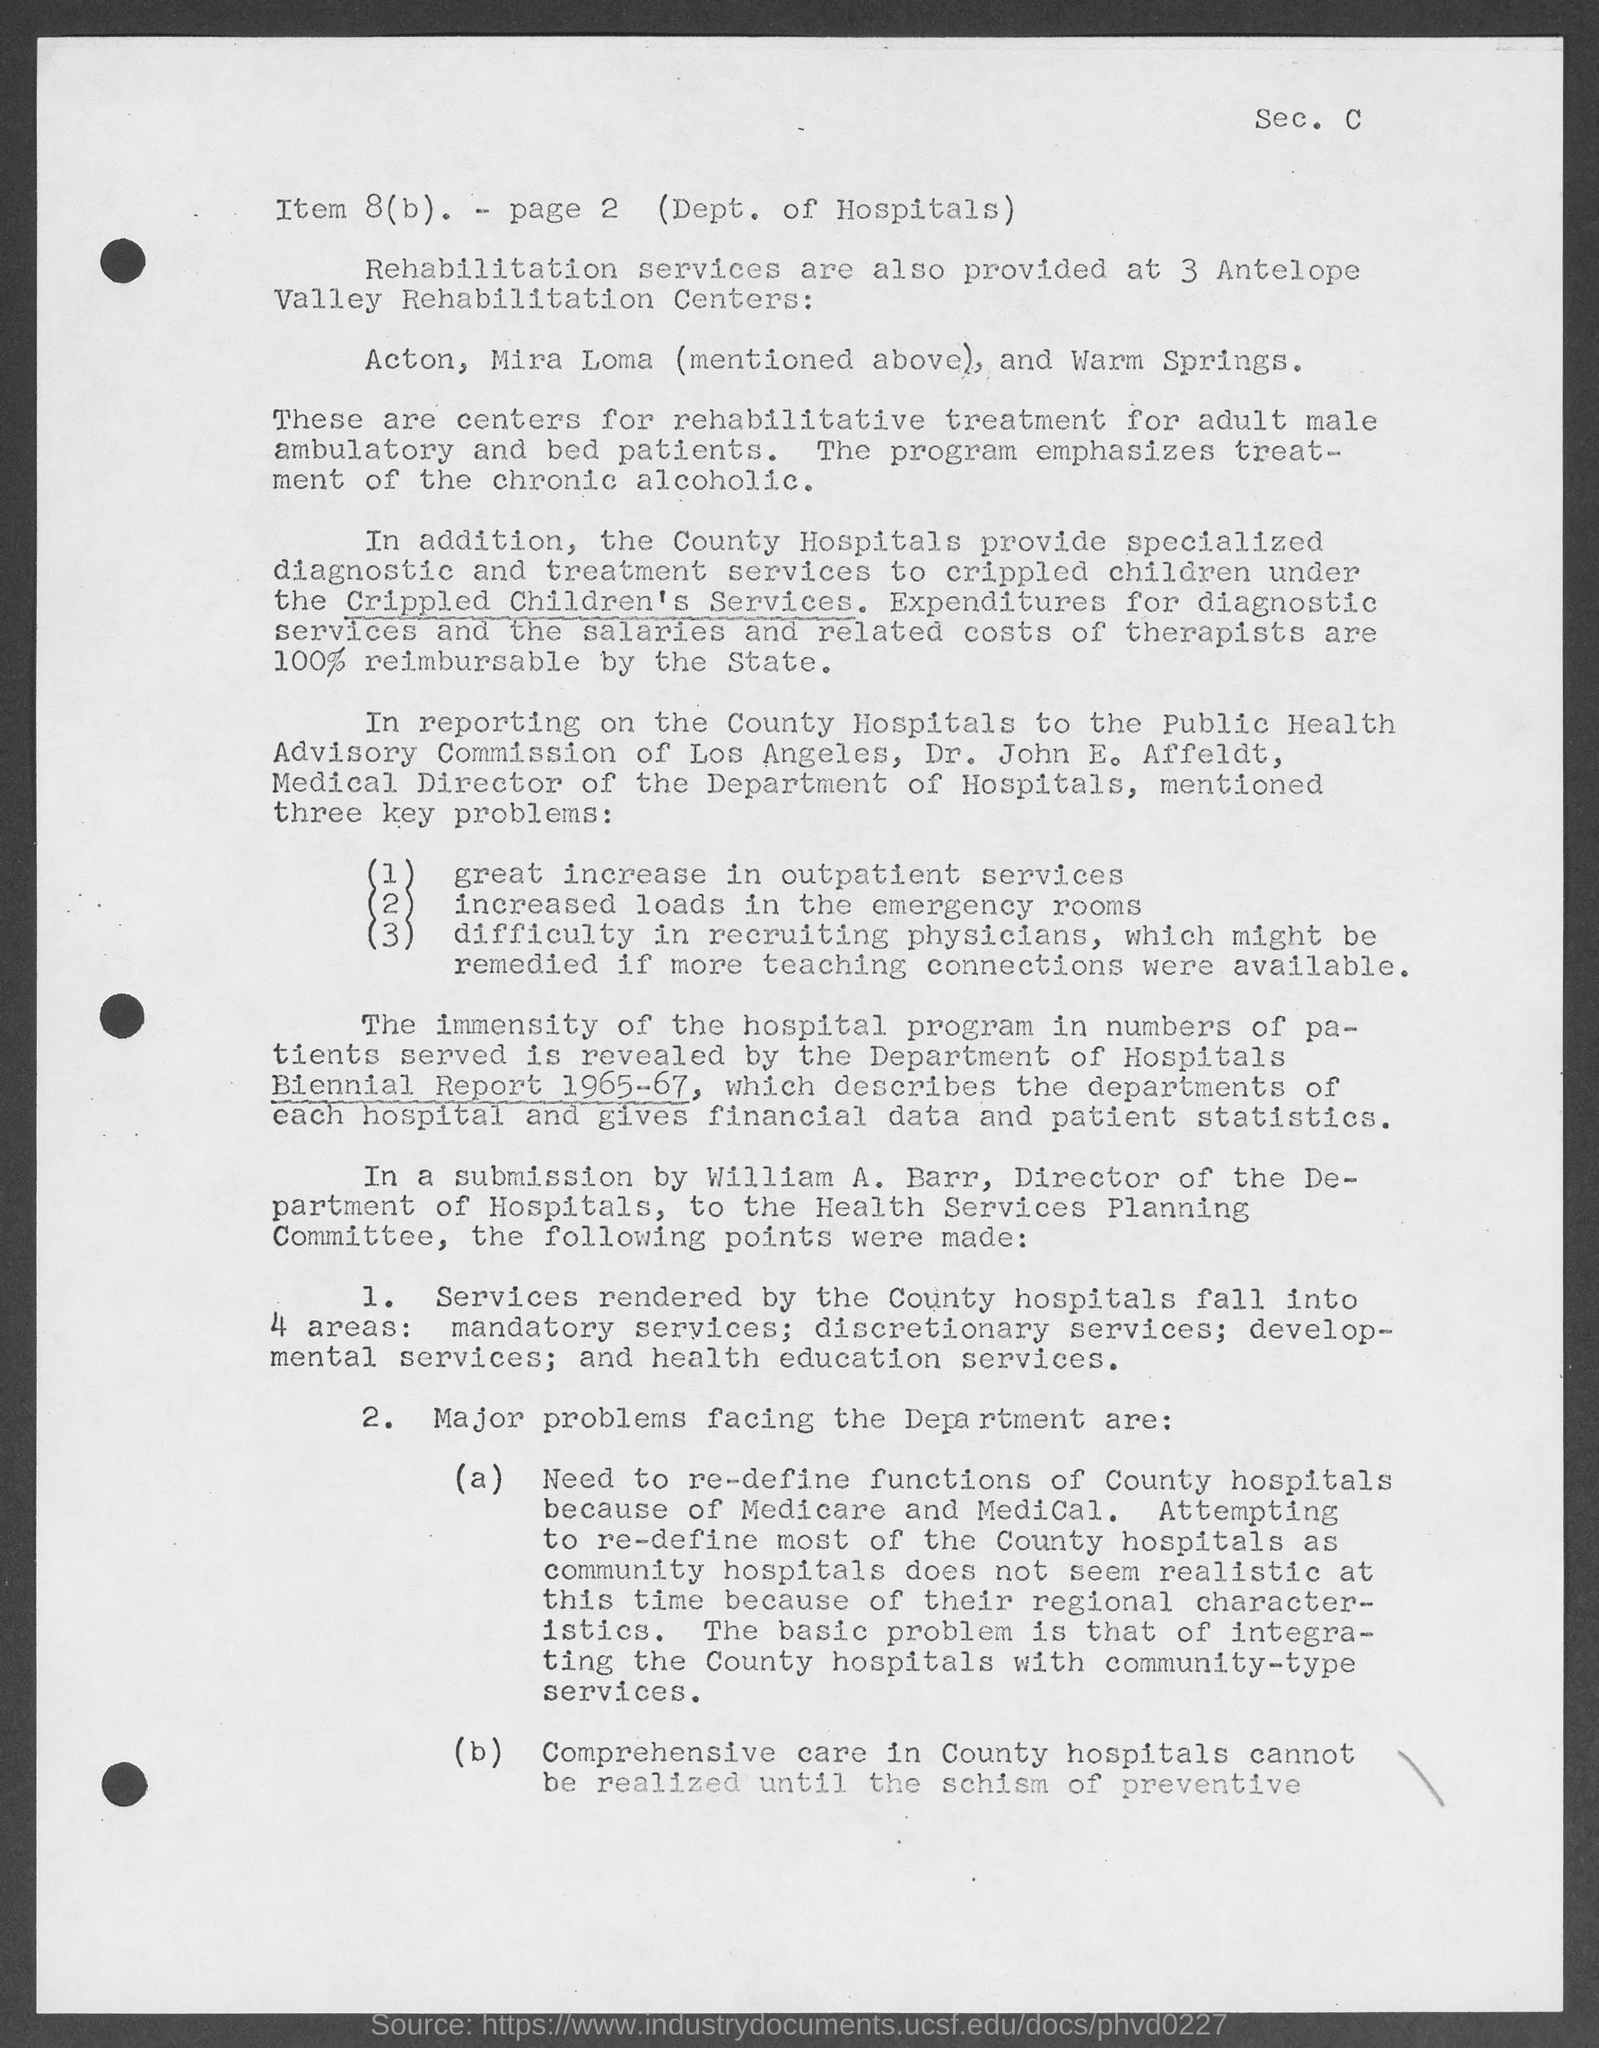Identify some key points in this picture. The top-right corner of the document contains the section 'C..'. 